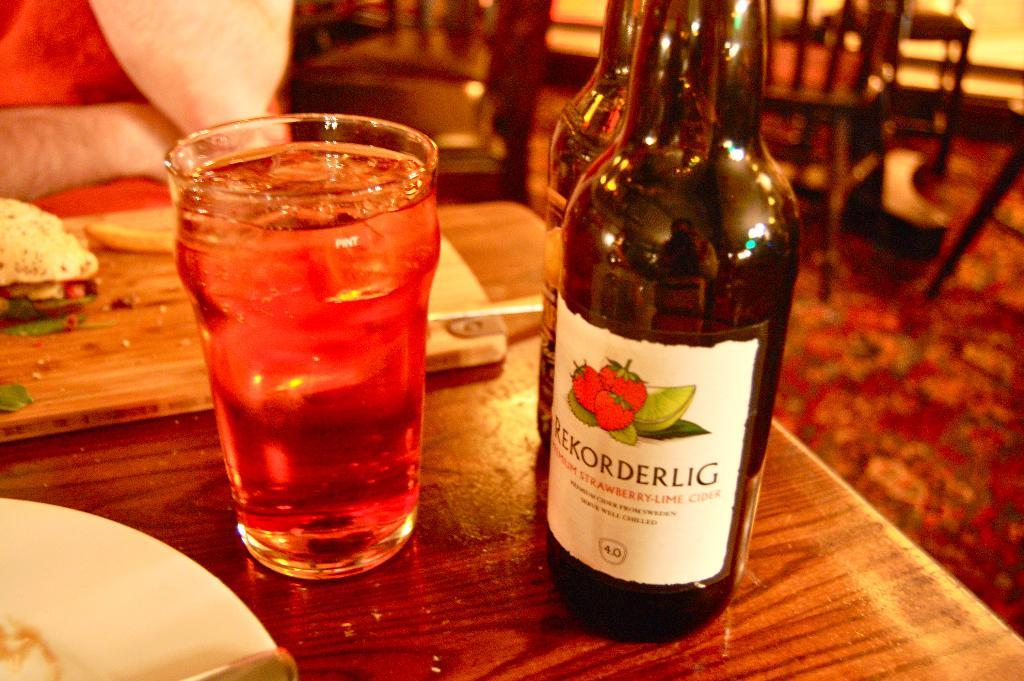<image>
Write a terse but informative summary of the picture. strawberry lime drink is in s glass beside the bottle that it came in 